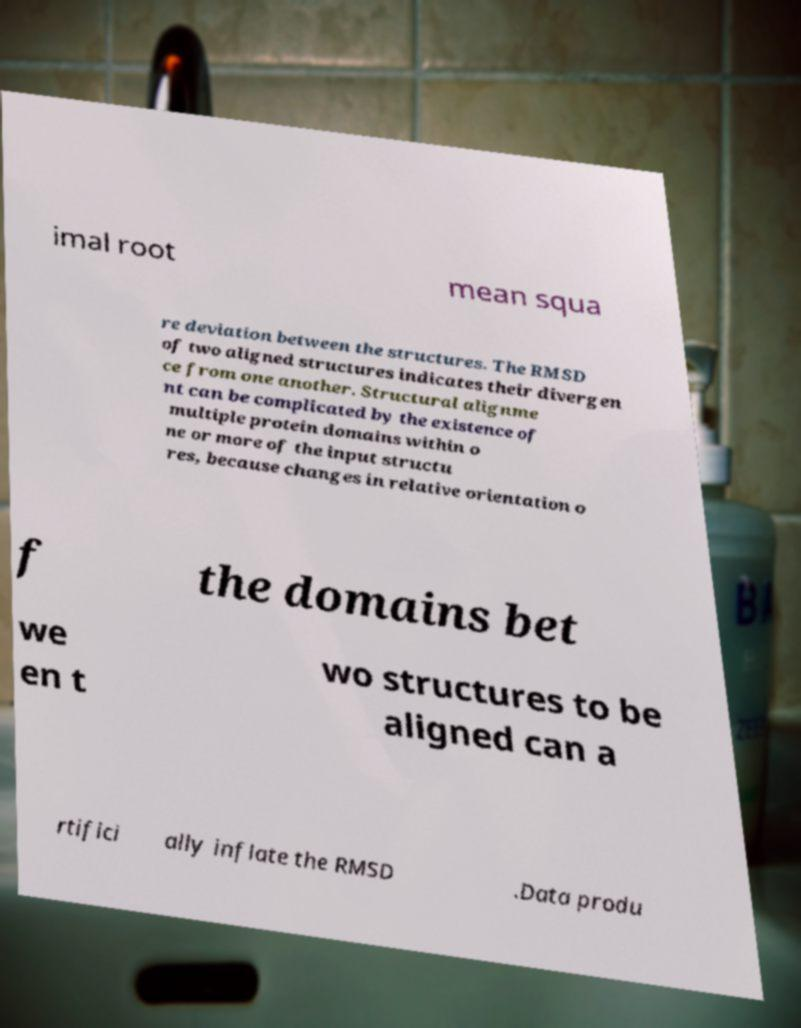Could you assist in decoding the text presented in this image and type it out clearly? imal root mean squa re deviation between the structures. The RMSD of two aligned structures indicates their divergen ce from one another. Structural alignme nt can be complicated by the existence of multiple protein domains within o ne or more of the input structu res, because changes in relative orientation o f the domains bet we en t wo structures to be aligned can a rtifici ally inflate the RMSD .Data produ 